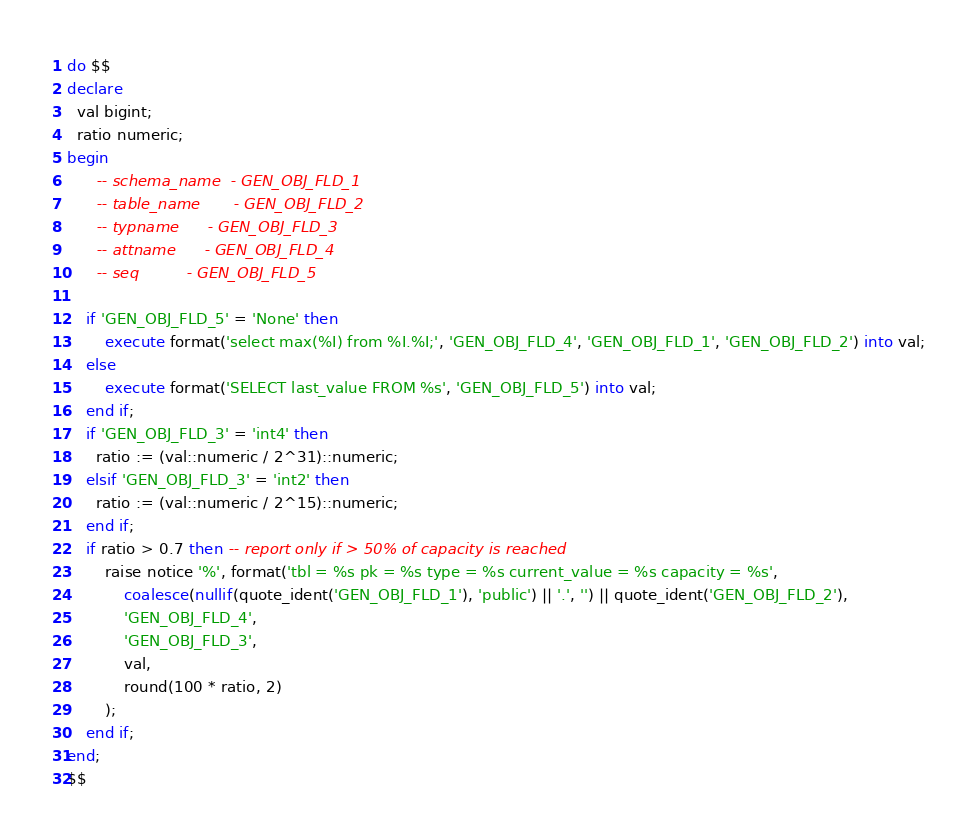<code> <loc_0><loc_0><loc_500><loc_500><_SQL_>do $$
declare
  val bigint;
  ratio numeric;
begin
      -- schema_name	- GEN_OBJ_FLD_1
      -- table_name		- GEN_OBJ_FLD_2
      -- typname		- GEN_OBJ_FLD_3
      -- attname		- GEN_OBJ_FLD_4
      -- seq			- GEN_OBJ_FLD_5

    if 'GEN_OBJ_FLD_5' = 'None' then
        execute format('select max(%I) from %I.%I;', 'GEN_OBJ_FLD_4', 'GEN_OBJ_FLD_1', 'GEN_OBJ_FLD_2') into val;
    else
        execute format('SELECT last_value FROM %s', 'GEN_OBJ_FLD_5') into val;
    end if;
    if 'GEN_OBJ_FLD_3' = 'int4' then
      ratio := (val::numeric / 2^31)::numeric;
    elsif 'GEN_OBJ_FLD_3' = 'int2' then
      ratio := (val::numeric / 2^15)::numeric;
    end if;
    if ratio > 0.7 then -- report only if > 50% of capacity is reached
		raise notice '%', format('tbl = %s pk = %s type = %s current_value = %s capacity = %s',
			coalesce(nullif(quote_ident('GEN_OBJ_FLD_1'), 'public') || '.', '') || quote_ident('GEN_OBJ_FLD_2'),
			'GEN_OBJ_FLD_4',
			'GEN_OBJ_FLD_3',
			val,
			round(100 * ratio, 2)
		);
    end if;
end;
$$</code> 